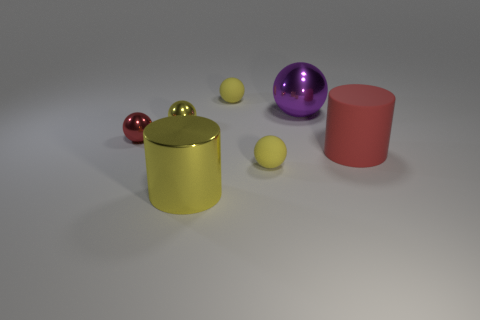How many yellow balls must be subtracted to get 1 yellow balls? 2 Subtract all blue cylinders. How many yellow balls are left? 3 Subtract all big purple balls. How many balls are left? 4 Add 2 yellow spheres. How many objects exist? 9 Subtract all purple spheres. How many spheres are left? 4 Subtract 3 balls. How many balls are left? 2 Subtract 1 red spheres. How many objects are left? 6 Subtract all cylinders. How many objects are left? 5 Subtract all green cylinders. Subtract all purple blocks. How many cylinders are left? 2 Subtract all red objects. Subtract all yellow matte spheres. How many objects are left? 3 